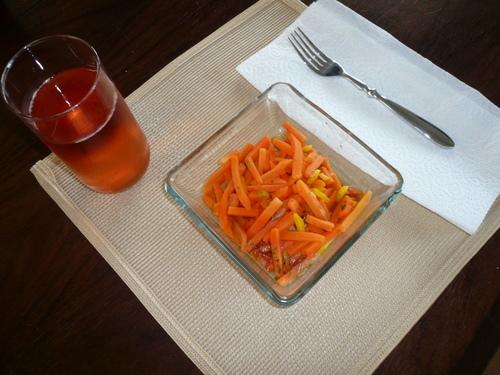Is the glass full of water?
Short answer required. No. What color is the bowl?
Short answer required. Clear. How many different kinds of food are there?
Answer briefly. 1. What kind of food is this?
Answer briefly. Carrots. 